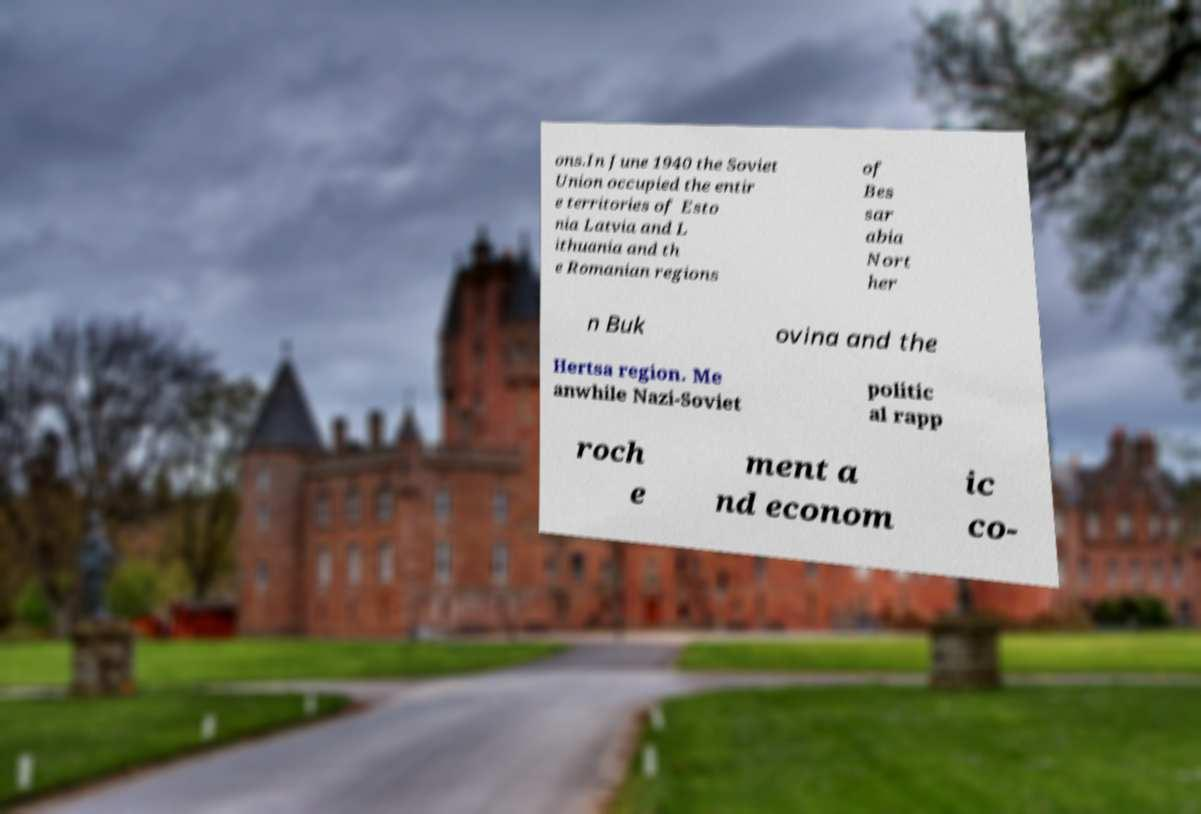Please identify and transcribe the text found in this image. ons.In June 1940 the Soviet Union occupied the entir e territories of Esto nia Latvia and L ithuania and th e Romanian regions of Bes sar abia Nort her n Buk ovina and the Hertsa region. Me anwhile Nazi-Soviet politic al rapp roch e ment a nd econom ic co- 